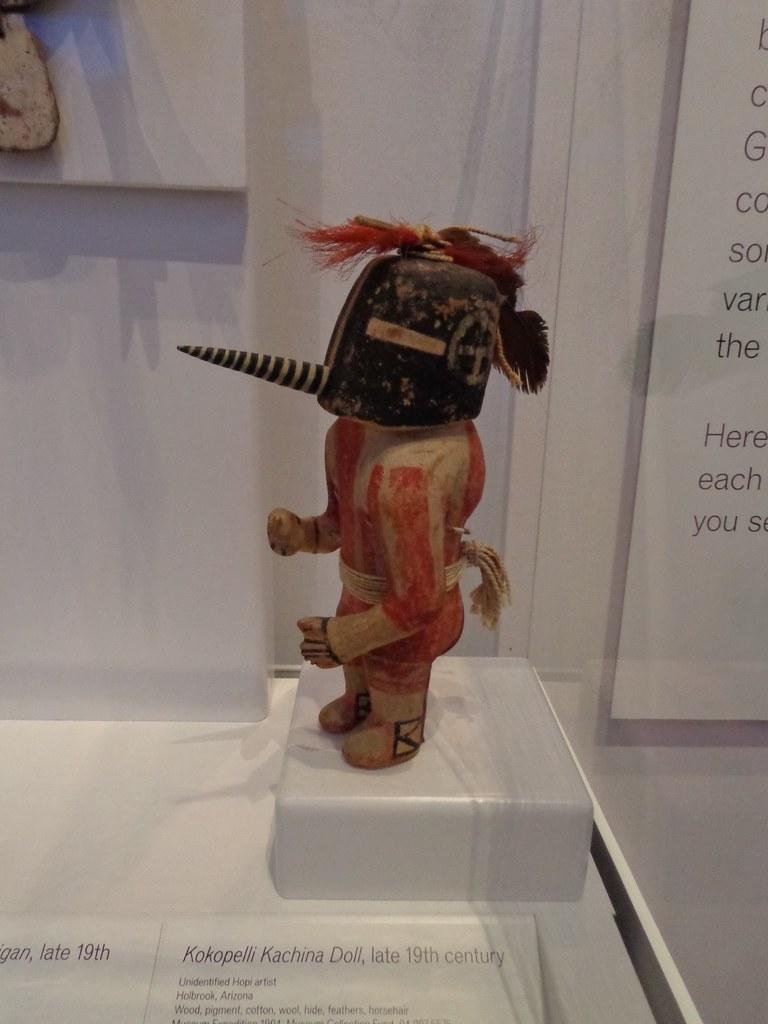What is the main object on the white colored surface in the image? The main object on the white colored surface is not specified in the facts provided. What can be seen on the wall in the image? There is an object on the wall in the image. What type of object is present on the board in the image? There is a board with text in the image. What additional text can be found in the image? There is some text visible at the bottom of the image. What type of soup is being served in the image? There is no soup present in the image. What kind of pest can be seen crawling on the wall in the image? There is no pest visible in the image. 